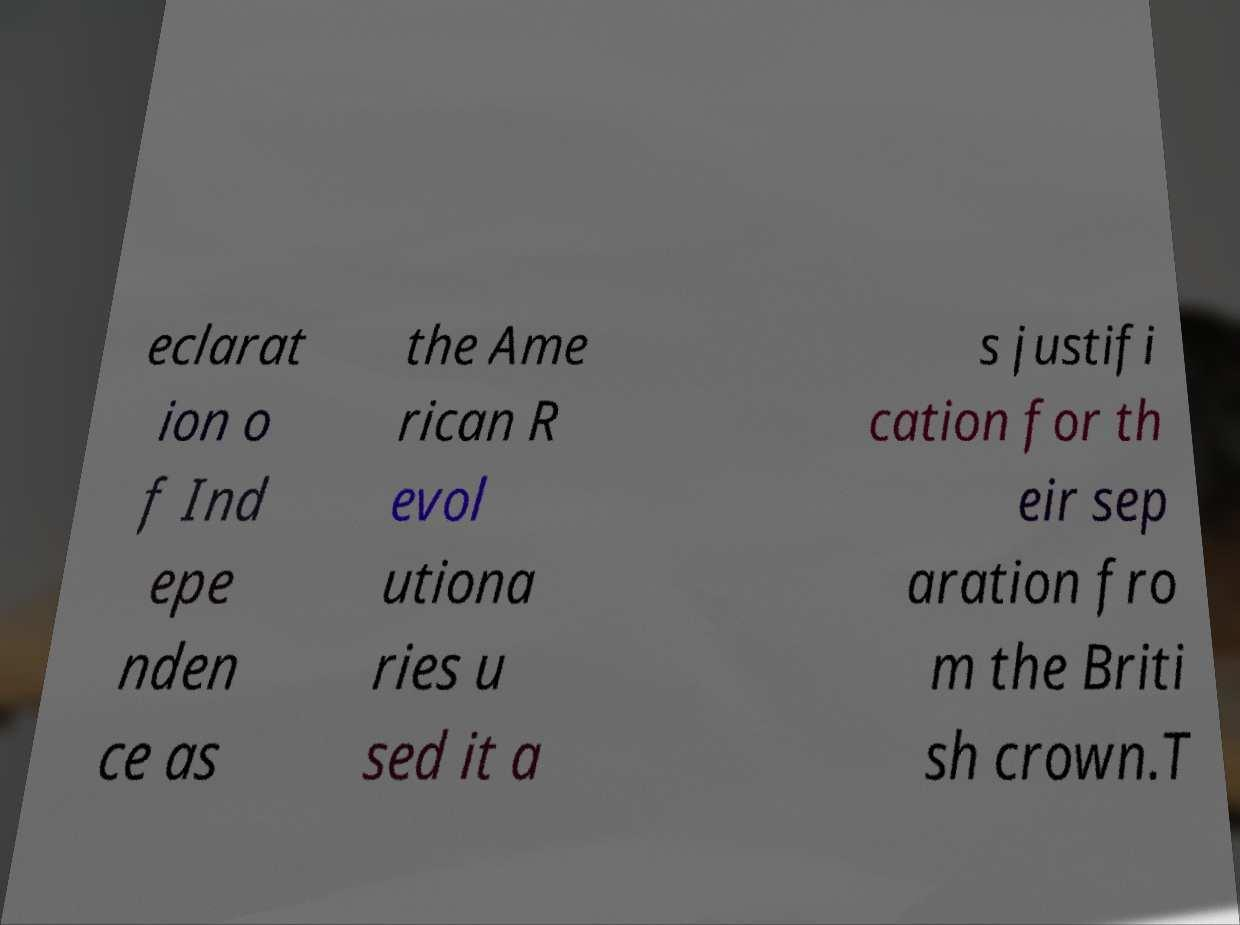I need the written content from this picture converted into text. Can you do that? eclarat ion o f Ind epe nden ce as the Ame rican R evol utiona ries u sed it a s justifi cation for th eir sep aration fro m the Briti sh crown.T 